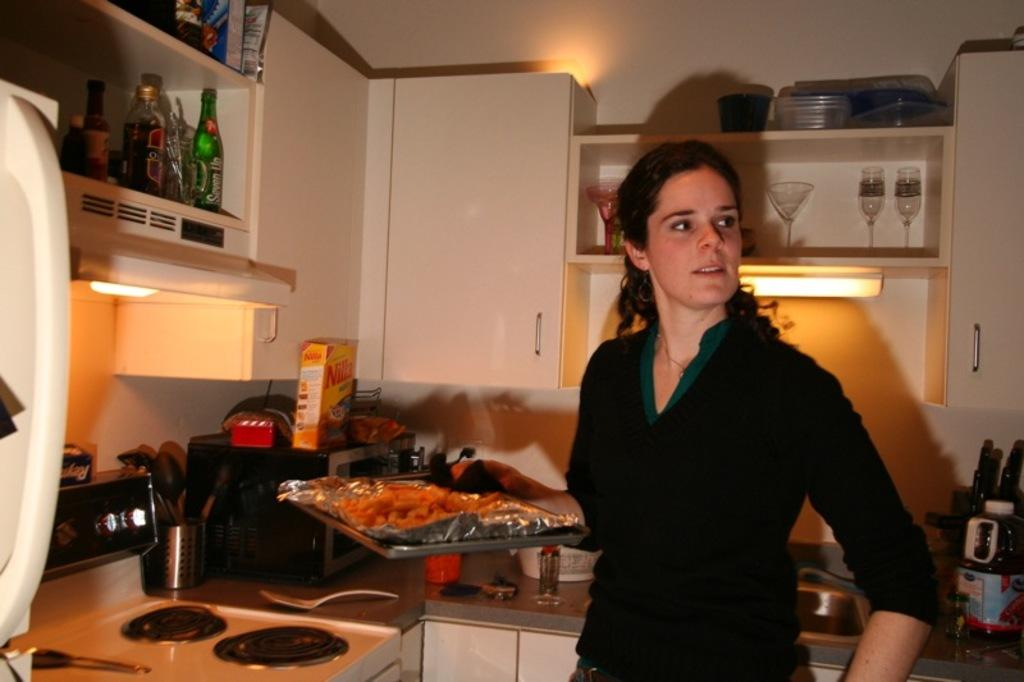<image>
Give a short and clear explanation of the subsequent image. a woman cooking in the kitchen with a box of nilla wafers in the corner 